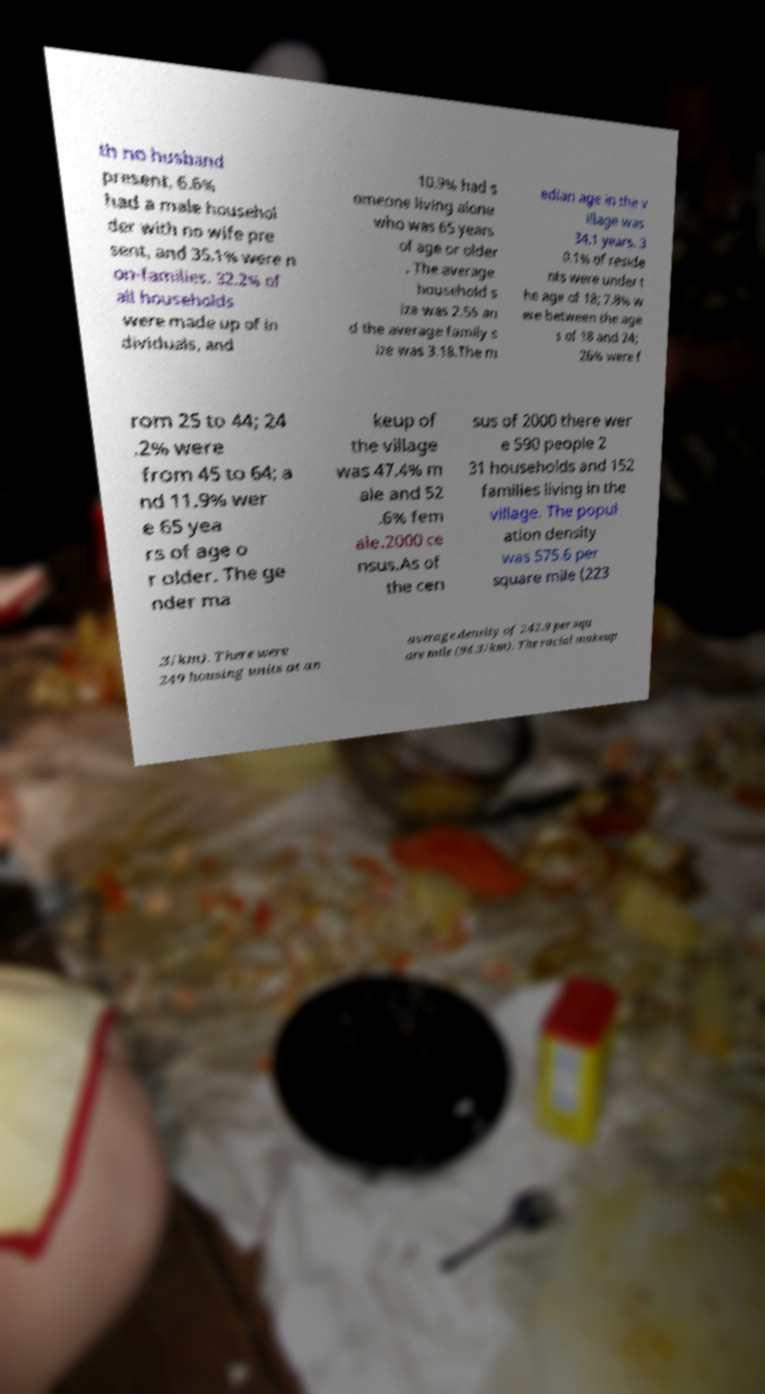I need the written content from this picture converted into text. Can you do that? th no husband present, 6.6% had a male househol der with no wife pre sent, and 35.1% were n on-families. 32.2% of all households were made up of in dividuals, and 10.9% had s omeone living alone who was 65 years of age or older . The average household s ize was 2.55 an d the average family s ize was 3.18.The m edian age in the v illage was 34.1 years. 3 0.1% of reside nts were under t he age of 18; 7.8% w ere between the age s of 18 and 24; 26% were f rom 25 to 44; 24 .2% were from 45 to 64; a nd 11.9% wer e 65 yea rs of age o r older. The ge nder ma keup of the village was 47.4% m ale and 52 .6% fem ale.2000 ce nsus.As of the cen sus of 2000 there wer e 590 people 2 31 households and 152 families living in the village. The popul ation density was 575.6 per square mile (223 .3/km). There were 249 housing units at an average density of 242.9 per squ are mile (94.3/km). The racial makeup 